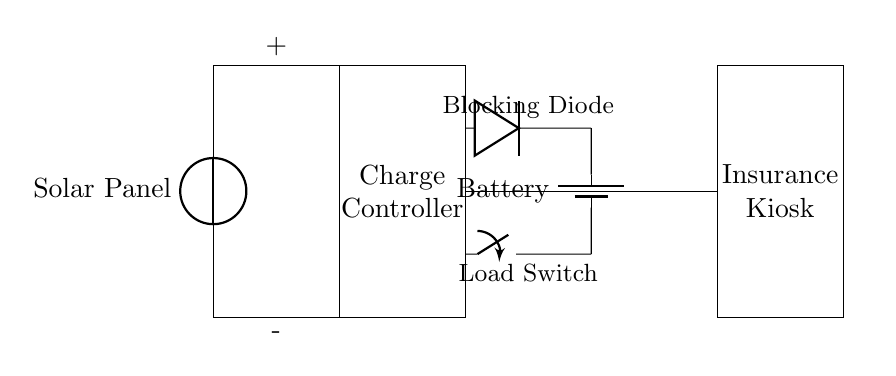What type of solar device is used here? The circuit diagram shows a solar panel as the source of energy. The label indicates that it is a solar panel, capturing sunlight and converting it into electrical energy.
Answer: Solar Panel What component regulates the battery charging? The charge controller is a critical component that ensures the battery is charged properly and protects it from overcharging or discharging. Its presence is indicated in the diagram.
Answer: Charge Controller Where does the load connect in the circuit? The load, which is the insurance kiosk, connects to the circuit through a conductive path towards the right after the battery. This portion of the diagram clearly shows the connection.
Answer: Insurance Kiosk What is the purpose of the blocking diode? The blocking diode prevents backflow of current from the battery to the solar panel, ensuring that energy flows only in one direction, which is essential for proper functioning and safety of the circuit.
Answer: Prevents backflow What is the total number of components shown in this diagram? The components include a solar panel, a charge controller, a battery, an insurance kiosk (load), a blocking diode, and a switch. Counting these yields a total of six distinct components.
Answer: Six How does the switch affect the circuit operation? The switch allows control over the circuit's operation by connecting or disconnecting the load from the battery. When closed, it completes the circuit; when opened, it interrupts the current flow to the load.
Answer: Controls load operation 